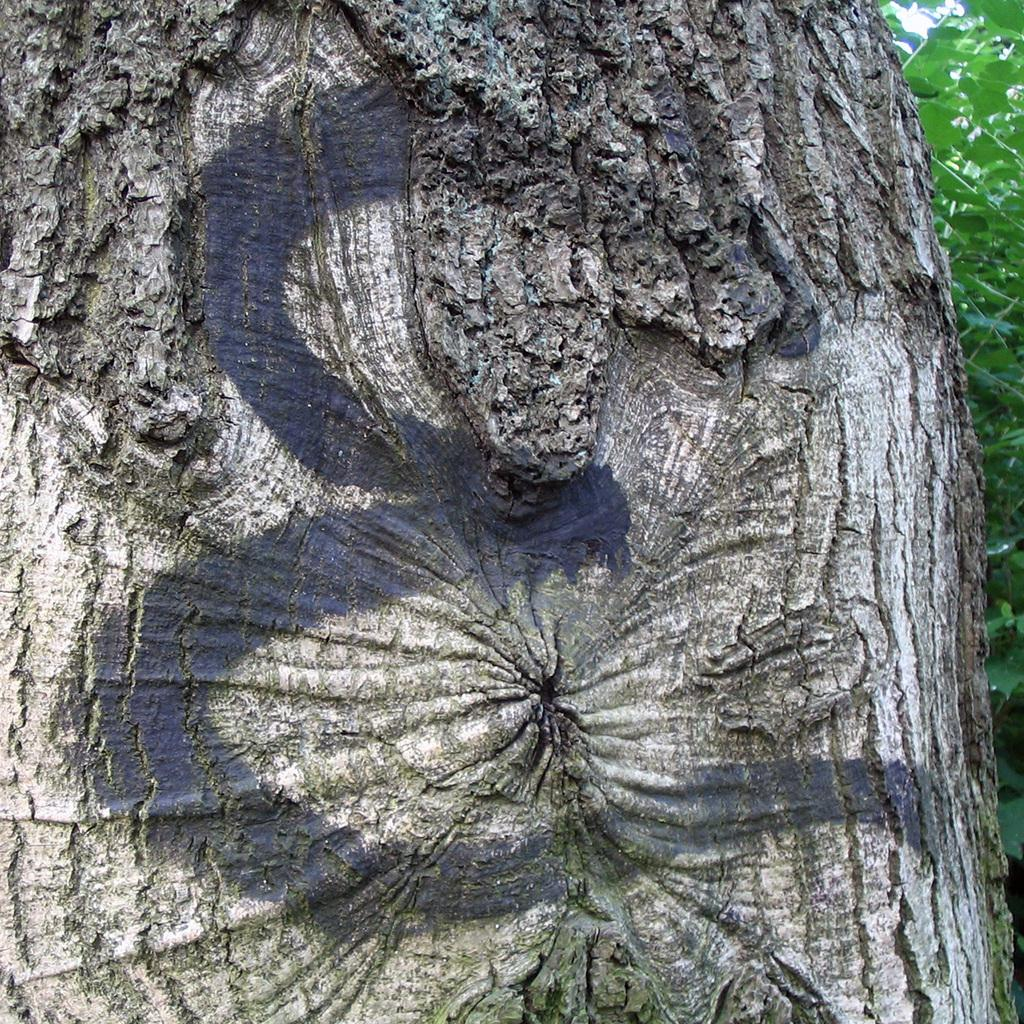What is the main object in the image with text written on it? There is wood with text written on it in the image. What type of vegetation can be seen on the right side of the image? There are trees on the right side of the image. Can you tell me how many beggars are visible near the coast in the image? There are no beggars or coast visible in the image; it only features wood with text and trees. 